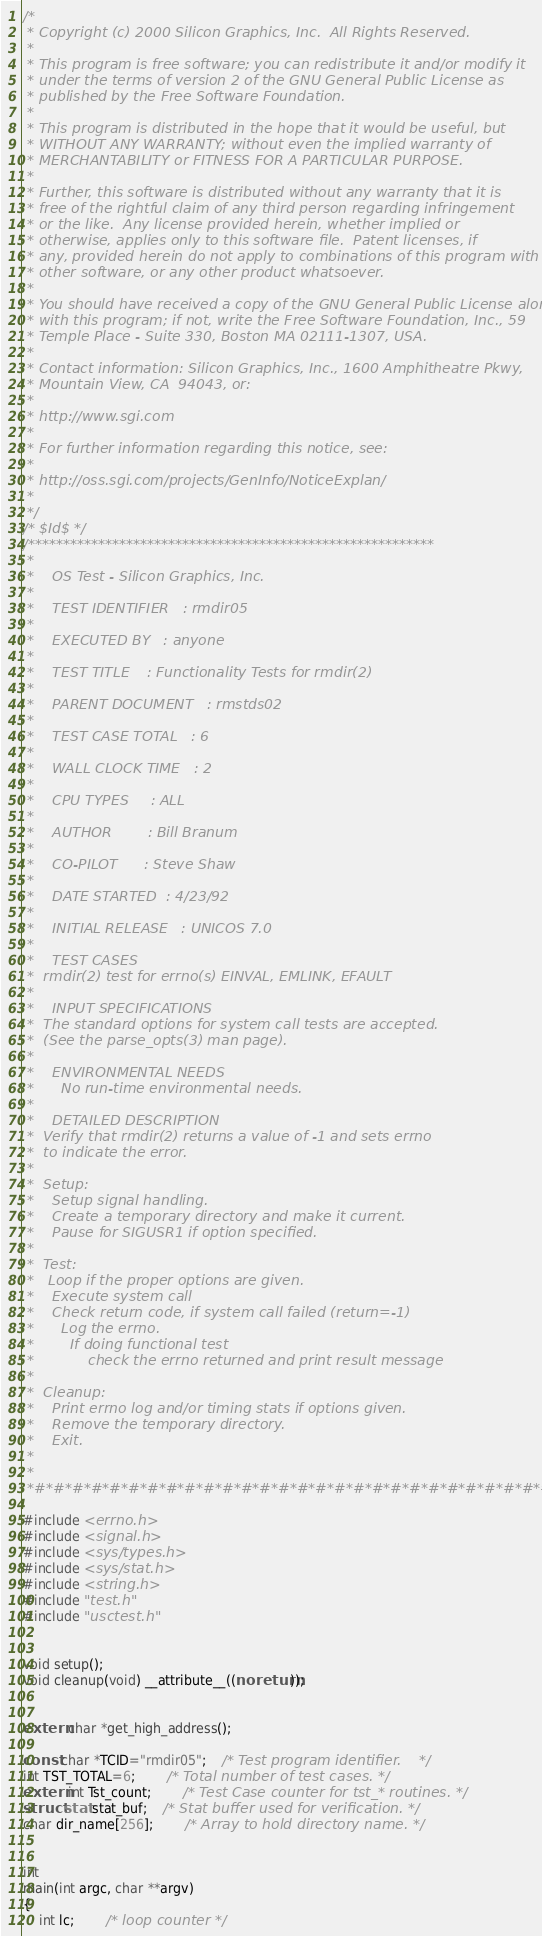Convert code to text. <code><loc_0><loc_0><loc_500><loc_500><_C_>/*
 * Copyright (c) 2000 Silicon Graphics, Inc.  All Rights Reserved.
 *
 * This program is free software; you can redistribute it and/or modify it
 * under the terms of version 2 of the GNU General Public License as
 * published by the Free Software Foundation.
 *
 * This program is distributed in the hope that it would be useful, but
 * WITHOUT ANY WARRANTY; without even the implied warranty of
 * MERCHANTABILITY or FITNESS FOR A PARTICULAR PURPOSE.
 *
 * Further, this software is distributed without any warranty that it is
 * free of the rightful claim of any third person regarding infringement
 * or the like.  Any license provided herein, whether implied or
 * otherwise, applies only to this software file.  Patent licenses, if
 * any, provided herein do not apply to combinations of this program with
 * other software, or any other product whatsoever.
 *
 * You should have received a copy of the GNU General Public License along
 * with this program; if not, write the Free Software Foundation, Inc., 59
 * Temple Place - Suite 330, Boston MA 02111-1307, USA.
 *
 * Contact information: Silicon Graphics, Inc., 1600 Amphitheatre Pkwy,
 * Mountain View, CA  94043, or:
 *
 * http://www.sgi.com
 *
 * For further information regarding this notice, see:
 *
 * http://oss.sgi.com/projects/GenInfo/NoticeExplan/
 *
 */
/* $Id$ */
/**********************************************************
 * 
 *    OS Test - Silicon Graphics, Inc.
 * 
 *    TEST IDENTIFIER	: rmdir05
 * 
 *    EXECUTED BY	: anyone
 * 
 *    TEST TITLE	: Functionality Tests for rmdir(2)
 * 
 *    PARENT DOCUMENT	: rmstds02
 * 
 *    TEST CASE TOTAL	: 6
 * 
 *    WALL CLOCK TIME	: 2
 * 
 *    CPU TYPES		: ALL
 * 
 *    AUTHOR		: Bill Branum
 * 
 *    CO-PILOT		: Steve Shaw
 * 
 *    DATE STARTED	: 4/23/92
 * 
 *    INITIAL RELEASE	: UNICOS 7.0
 * 
 *    TEST CASES
 * 	rmdir(2) test for errno(s) EINVAL, EMLINK, EFAULT
 *	
 *    INPUT SPECIFICATIONS
 * 	The standard options for system call tests are accepted.
 *	(See the parse_opts(3) man page).
 * 
 *    ENVIRONMENTAL NEEDS
 *      No run-time environmental needs.
 * 
 *    DETAILED DESCRIPTION
 *	Verify that rmdir(2) returns a value of -1 and sets errno
 *	to indicate the error.
 * 
 * 	Setup:
 * 	  Setup signal handling.
 *	  Create a temporary directory and make it current.
 *	  Pause for SIGUSR1 if option specified.
 * 
 * 	Test:
 *	 Loop if the proper options are given.
 * 	  Execute system call
 *	  Check return code, if system call failed (return=-1)
 *		Log the errno.
 *        If doing functional test
 *            check the errno returned and print result message
 * 
 * 	Cleanup:
 * 	  Print errno log and/or timing stats if options given.
 *	  Remove the temporary directory.
 *	  Exit.
 * 
 * 
 *#*#*#*#*#*#*#*#*#*#*#*#*#*#*#*#*#*#*#*#*#*#*#*#*#*#*#*#*#**/

#include <errno.h>
#include <signal.h>
#include <sys/types.h>
#include <sys/stat.h>
#include <string.h>
#include "test.h"
#include "usctest.h"


void setup();
void cleanup(void) __attribute__((noreturn));


extern char *get_high_address();

const char *TCID="rmdir05";	/* Test program identifier.    */
int TST_TOTAL=6;		/* Total number of test cases. */
extern int Tst_count;		/* Test Case counter for tst_* routines. */
struct stat stat_buf;   	/* Stat buffer used for verification. */
char dir_name[256];		/* Array to hold directory name. */


int
main(int argc, char **argv)
{
    int lc;		/* loop counter */</code> 